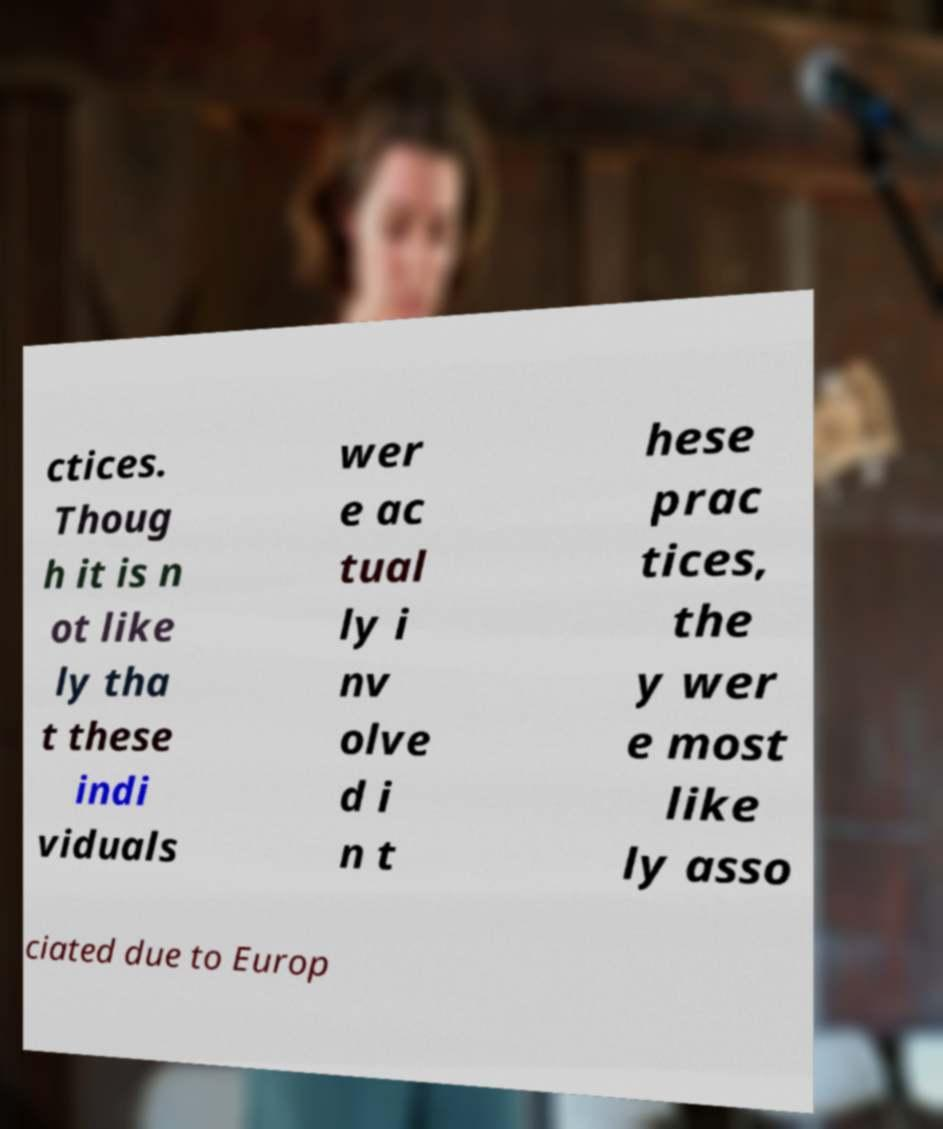Could you extract and type out the text from this image? ctices. Thoug h it is n ot like ly tha t these indi viduals wer e ac tual ly i nv olve d i n t hese prac tices, the y wer e most like ly asso ciated due to Europ 